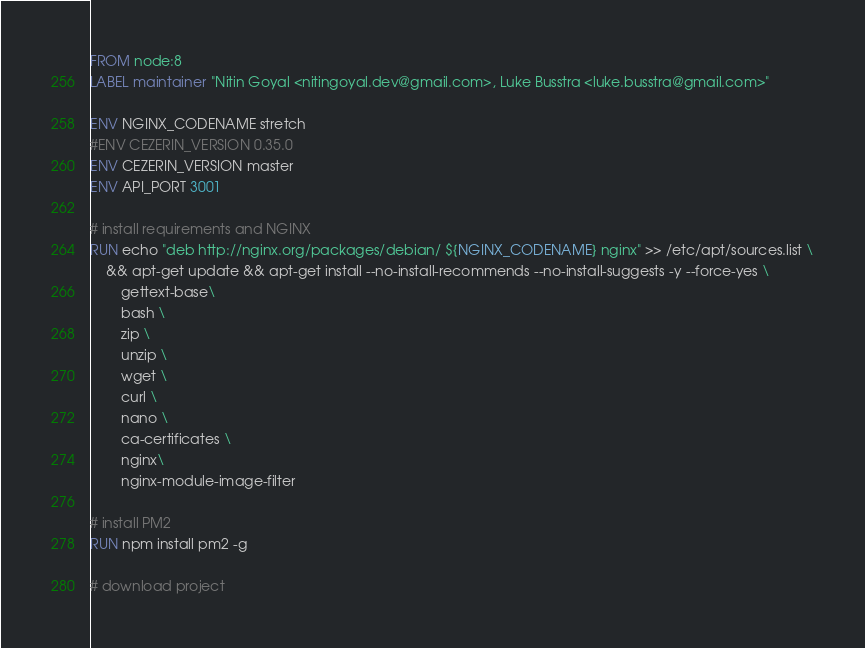<code> <loc_0><loc_0><loc_500><loc_500><_Dockerfile_>FROM node:8
LABEL maintainer "Nitin Goyal <nitingoyal.dev@gmail.com>, Luke Busstra <luke.busstra@gmail.com>"

ENV NGINX_CODENAME stretch
#ENV CEZERIN_VERSION 0.35.0
ENV CEZERIN_VERSION master
ENV API_PORT 3001

# install requirements and NGINX
RUN echo "deb http://nginx.org/packages/debian/ ${NGINX_CODENAME} nginx" >> /etc/apt/sources.list \
	&& apt-get update && apt-get install --no-install-recommends --no-install-suggests -y --force-yes \
		gettext-base\
		bash \
		zip \
		unzip \
		wget \
		curl \
		nano \
		ca-certificates \
		nginx\
		nginx-module-image-filter

# install PM2
RUN npm install pm2 -g

# download project</code> 